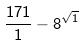Convert formula to latex. <formula><loc_0><loc_0><loc_500><loc_500>\frac { 1 7 1 } { 1 } - 8 ^ { \sqrt { 1 } }</formula> 